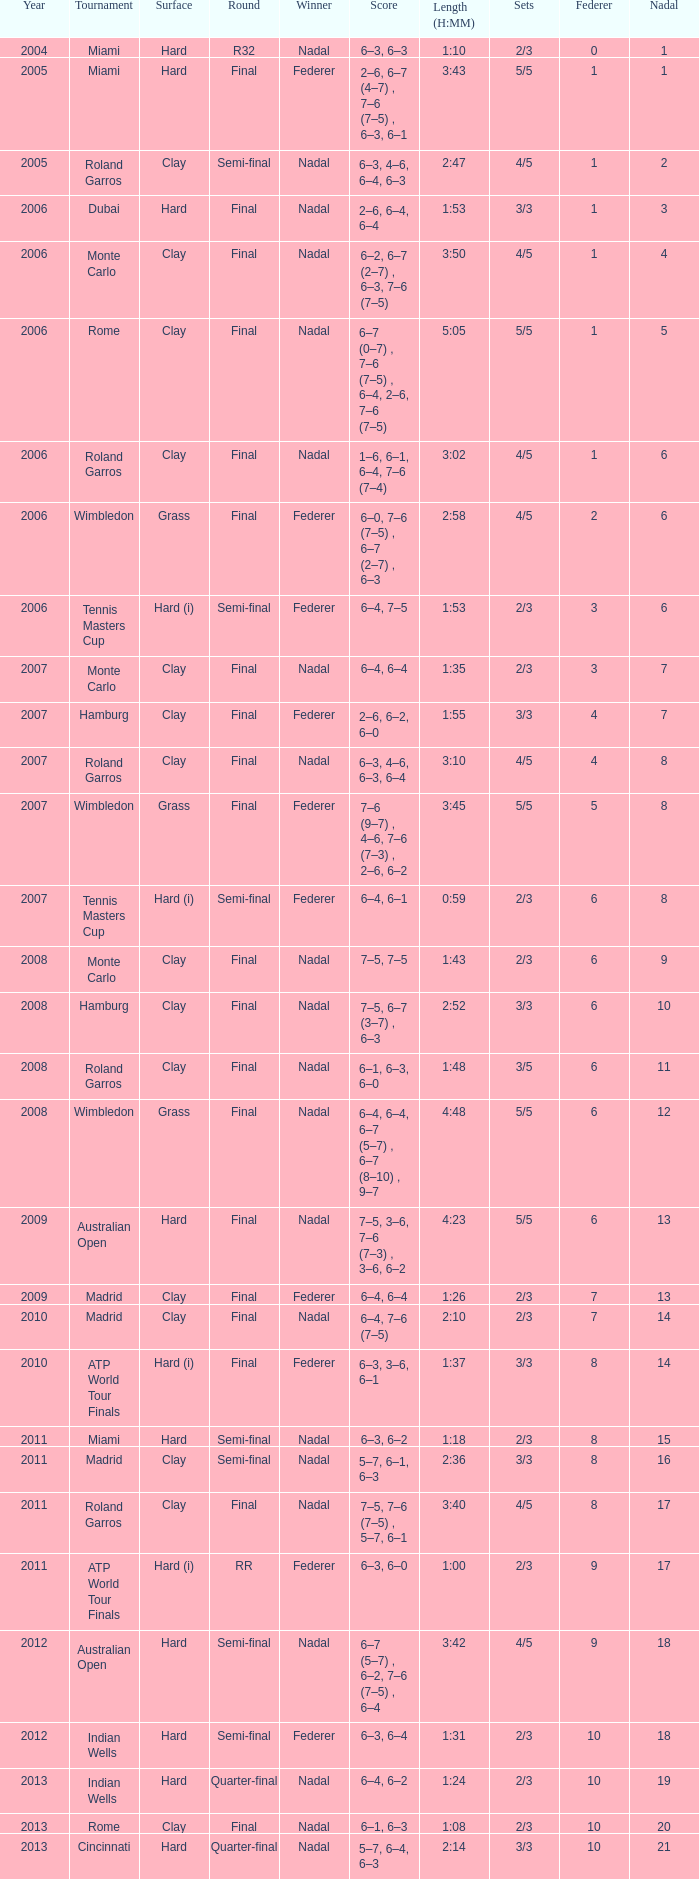Parse the table in full. {'header': ['Year', 'Tournament', 'Surface', 'Round', 'Winner', 'Score', 'Length (H:MM)', 'Sets', 'Federer', 'Nadal'], 'rows': [['2004', 'Miami', 'Hard', 'R32', 'Nadal', '6–3, 6–3', '1:10', '2/3', '0', '1'], ['2005', 'Miami', 'Hard', 'Final', 'Federer', '2–6, 6–7 (4–7) , 7–6 (7–5) , 6–3, 6–1', '3:43', '5/5', '1', '1'], ['2005', 'Roland Garros', 'Clay', 'Semi-final', 'Nadal', '6–3, 4–6, 6–4, 6–3', '2:47', '4/5', '1', '2'], ['2006', 'Dubai', 'Hard', 'Final', 'Nadal', '2–6, 6–4, 6–4', '1:53', '3/3', '1', '3'], ['2006', 'Monte Carlo', 'Clay', 'Final', 'Nadal', '6–2, 6–7 (2–7) , 6–3, 7–6 (7–5)', '3:50', '4/5', '1', '4'], ['2006', 'Rome', 'Clay', 'Final', 'Nadal', '6–7 (0–7) , 7–6 (7–5) , 6–4, 2–6, 7–6 (7–5)', '5:05', '5/5', '1', '5'], ['2006', 'Roland Garros', 'Clay', 'Final', 'Nadal', '1–6, 6–1, 6–4, 7–6 (7–4)', '3:02', '4/5', '1', '6'], ['2006', 'Wimbledon', 'Grass', 'Final', 'Federer', '6–0, 7–6 (7–5) , 6–7 (2–7) , 6–3', '2:58', '4/5', '2', '6'], ['2006', 'Tennis Masters Cup', 'Hard (i)', 'Semi-final', 'Federer', '6–4, 7–5', '1:53', '2/3', '3', '6'], ['2007', 'Monte Carlo', 'Clay', 'Final', 'Nadal', '6–4, 6–4', '1:35', '2/3', '3', '7'], ['2007', 'Hamburg', 'Clay', 'Final', 'Federer', '2–6, 6–2, 6–0', '1:55', '3/3', '4', '7'], ['2007', 'Roland Garros', 'Clay', 'Final', 'Nadal', '6–3, 4–6, 6–3, 6–4', '3:10', '4/5', '4', '8'], ['2007', 'Wimbledon', 'Grass', 'Final', 'Federer', '7–6 (9–7) , 4–6, 7–6 (7–3) , 2–6, 6–2', '3:45', '5/5', '5', '8'], ['2007', 'Tennis Masters Cup', 'Hard (i)', 'Semi-final', 'Federer', '6–4, 6–1', '0:59', '2/3', '6', '8'], ['2008', 'Monte Carlo', 'Clay', 'Final', 'Nadal', '7–5, 7–5', '1:43', '2/3', '6', '9'], ['2008', 'Hamburg', 'Clay', 'Final', 'Nadal', '7–5, 6–7 (3–7) , 6–3', '2:52', '3/3', '6', '10'], ['2008', 'Roland Garros', 'Clay', 'Final', 'Nadal', '6–1, 6–3, 6–0', '1:48', '3/5', '6', '11'], ['2008', 'Wimbledon', 'Grass', 'Final', 'Nadal', '6–4, 6–4, 6–7 (5–7) , 6–7 (8–10) , 9–7', '4:48', '5/5', '6', '12'], ['2009', 'Australian Open', 'Hard', 'Final', 'Nadal', '7–5, 3–6, 7–6 (7–3) , 3–6, 6–2', '4:23', '5/5', '6', '13'], ['2009', 'Madrid', 'Clay', 'Final', 'Federer', '6–4, 6–4', '1:26', '2/3', '7', '13'], ['2010', 'Madrid', 'Clay', 'Final', 'Nadal', '6–4, 7–6 (7–5)', '2:10', '2/3', '7', '14'], ['2010', 'ATP World Tour Finals', 'Hard (i)', 'Final', 'Federer', '6–3, 3–6, 6–1', '1:37', '3/3', '8', '14'], ['2011', 'Miami', 'Hard', 'Semi-final', 'Nadal', '6–3, 6–2', '1:18', '2/3', '8', '15'], ['2011', 'Madrid', 'Clay', 'Semi-final', 'Nadal', '5–7, 6–1, 6–3', '2:36', '3/3', '8', '16'], ['2011', 'Roland Garros', 'Clay', 'Final', 'Nadal', '7–5, 7–6 (7–5) , 5–7, 6–1', '3:40', '4/5', '8', '17'], ['2011', 'ATP World Tour Finals', 'Hard (i)', 'RR', 'Federer', '6–3, 6–0', '1:00', '2/3', '9', '17'], ['2012', 'Australian Open', 'Hard', 'Semi-final', 'Nadal', '6–7 (5–7) , 6–2, 7–6 (7–5) , 6–4', '3:42', '4/5', '9', '18'], ['2012', 'Indian Wells', 'Hard', 'Semi-final', 'Federer', '6–3, 6–4', '1:31', '2/3', '10', '18'], ['2013', 'Indian Wells', 'Hard', 'Quarter-final', 'Nadal', '6–4, 6–2', '1:24', '2/3', '10', '19'], ['2013', 'Rome', 'Clay', 'Final', 'Nadal', '6–1, 6–3', '1:08', '2/3', '10', '20'], ['2013', 'Cincinnati', 'Hard', 'Quarter-final', 'Nadal', '5–7, 6–4, 6–3', '2:14', '3/3', '10', '21']]} Which contest did nadal succeed in and had a total of 16? Madrid. 